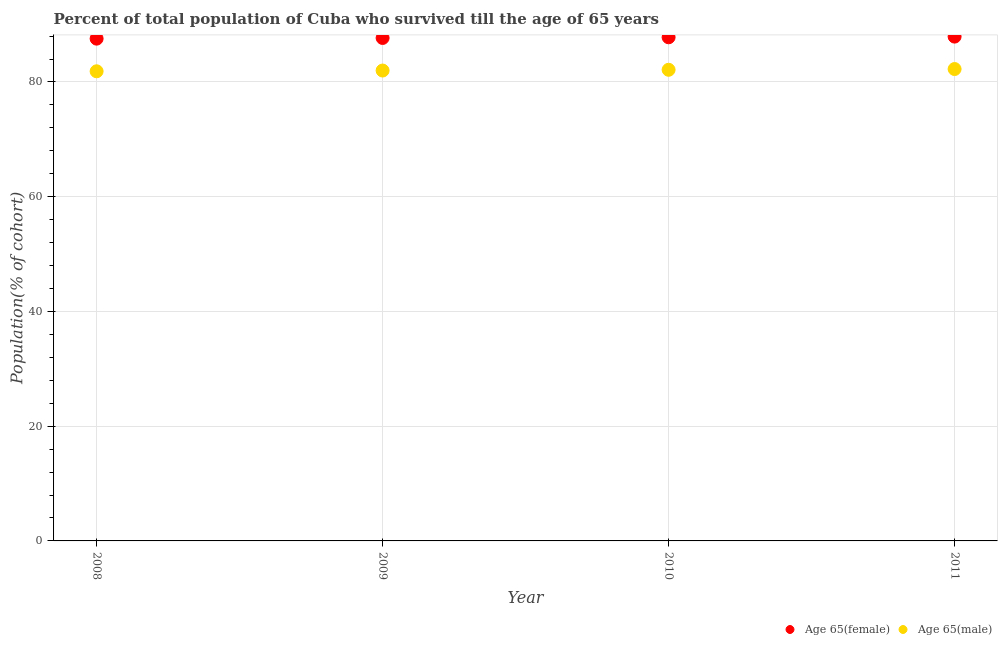How many different coloured dotlines are there?
Ensure brevity in your answer.  2. Is the number of dotlines equal to the number of legend labels?
Your response must be concise. Yes. What is the percentage of male population who survived till age of 65 in 2011?
Give a very brief answer. 82.26. Across all years, what is the maximum percentage of female population who survived till age of 65?
Keep it short and to the point. 87.91. Across all years, what is the minimum percentage of female population who survived till age of 65?
Provide a short and direct response. 87.55. In which year was the percentage of female population who survived till age of 65 minimum?
Your answer should be very brief. 2008. What is the total percentage of female population who survived till age of 65 in the graph?
Your answer should be compact. 350.92. What is the difference between the percentage of male population who survived till age of 65 in 2009 and that in 2011?
Your answer should be compact. -0.26. What is the difference between the percentage of female population who survived till age of 65 in 2010 and the percentage of male population who survived till age of 65 in 2008?
Your answer should be very brief. 5.93. What is the average percentage of male population who survived till age of 65 per year?
Your answer should be compact. 82.06. In the year 2008, what is the difference between the percentage of male population who survived till age of 65 and percentage of female population who survived till age of 65?
Offer a very short reply. -5.69. What is the ratio of the percentage of male population who survived till age of 65 in 2010 to that in 2011?
Provide a short and direct response. 1. Is the difference between the percentage of female population who survived till age of 65 in 2008 and 2009 greater than the difference between the percentage of male population who survived till age of 65 in 2008 and 2009?
Your answer should be very brief. Yes. What is the difference between the highest and the second highest percentage of female population who survived till age of 65?
Give a very brief answer. 0.12. What is the difference between the highest and the lowest percentage of male population who survived till age of 65?
Provide a short and direct response. 0.39. In how many years, is the percentage of male population who survived till age of 65 greater than the average percentage of male population who survived till age of 65 taken over all years?
Offer a terse response. 2. Is the sum of the percentage of male population who survived till age of 65 in 2008 and 2011 greater than the maximum percentage of female population who survived till age of 65 across all years?
Your answer should be very brief. Yes. Does the percentage of female population who survived till age of 65 monotonically increase over the years?
Ensure brevity in your answer.  Yes. Is the percentage of male population who survived till age of 65 strictly less than the percentage of female population who survived till age of 65 over the years?
Offer a terse response. Yes. What is the difference between two consecutive major ticks on the Y-axis?
Offer a terse response. 20. Are the values on the major ticks of Y-axis written in scientific E-notation?
Your response must be concise. No. Does the graph contain grids?
Provide a succinct answer. Yes. How many legend labels are there?
Provide a short and direct response. 2. How are the legend labels stacked?
Keep it short and to the point. Horizontal. What is the title of the graph?
Offer a terse response. Percent of total population of Cuba who survived till the age of 65 years. What is the label or title of the Y-axis?
Offer a terse response. Population(% of cohort). What is the Population(% of cohort) of Age 65(female) in 2008?
Provide a short and direct response. 87.55. What is the Population(% of cohort) in Age 65(male) in 2008?
Provide a succinct answer. 81.86. What is the Population(% of cohort) in Age 65(female) in 2009?
Provide a short and direct response. 87.67. What is the Population(% of cohort) in Age 65(male) in 2009?
Provide a succinct answer. 81.99. What is the Population(% of cohort) in Age 65(female) in 2010?
Offer a terse response. 87.79. What is the Population(% of cohort) in Age 65(male) in 2010?
Your answer should be very brief. 82.12. What is the Population(% of cohort) in Age 65(female) in 2011?
Ensure brevity in your answer.  87.91. What is the Population(% of cohort) in Age 65(male) in 2011?
Provide a short and direct response. 82.26. Across all years, what is the maximum Population(% of cohort) of Age 65(female)?
Keep it short and to the point. 87.91. Across all years, what is the maximum Population(% of cohort) in Age 65(male)?
Your answer should be compact. 82.26. Across all years, what is the minimum Population(% of cohort) in Age 65(female)?
Make the answer very short. 87.55. Across all years, what is the minimum Population(% of cohort) of Age 65(male)?
Provide a succinct answer. 81.86. What is the total Population(% of cohort) of Age 65(female) in the graph?
Ensure brevity in your answer.  350.92. What is the total Population(% of cohort) in Age 65(male) in the graph?
Ensure brevity in your answer.  328.24. What is the difference between the Population(% of cohort) in Age 65(female) in 2008 and that in 2009?
Provide a succinct answer. -0.12. What is the difference between the Population(% of cohort) of Age 65(male) in 2008 and that in 2009?
Your answer should be very brief. -0.13. What is the difference between the Population(% of cohort) in Age 65(female) in 2008 and that in 2010?
Provide a short and direct response. -0.24. What is the difference between the Population(% of cohort) in Age 65(male) in 2008 and that in 2010?
Provide a short and direct response. -0.26. What is the difference between the Population(% of cohort) of Age 65(female) in 2008 and that in 2011?
Ensure brevity in your answer.  -0.35. What is the difference between the Population(% of cohort) in Age 65(male) in 2008 and that in 2011?
Provide a short and direct response. -0.39. What is the difference between the Population(% of cohort) in Age 65(female) in 2009 and that in 2010?
Your answer should be very brief. -0.12. What is the difference between the Population(% of cohort) of Age 65(male) in 2009 and that in 2010?
Keep it short and to the point. -0.13. What is the difference between the Population(% of cohort) in Age 65(female) in 2009 and that in 2011?
Make the answer very short. -0.24. What is the difference between the Population(% of cohort) in Age 65(male) in 2009 and that in 2011?
Provide a short and direct response. -0.26. What is the difference between the Population(% of cohort) in Age 65(female) in 2010 and that in 2011?
Provide a short and direct response. -0.12. What is the difference between the Population(% of cohort) of Age 65(male) in 2010 and that in 2011?
Offer a very short reply. -0.13. What is the difference between the Population(% of cohort) of Age 65(female) in 2008 and the Population(% of cohort) of Age 65(male) in 2009?
Your response must be concise. 5.56. What is the difference between the Population(% of cohort) of Age 65(female) in 2008 and the Population(% of cohort) of Age 65(male) in 2010?
Ensure brevity in your answer.  5.43. What is the difference between the Population(% of cohort) in Age 65(female) in 2008 and the Population(% of cohort) in Age 65(male) in 2011?
Provide a succinct answer. 5.3. What is the difference between the Population(% of cohort) in Age 65(female) in 2009 and the Population(% of cohort) in Age 65(male) in 2010?
Your answer should be compact. 5.55. What is the difference between the Population(% of cohort) in Age 65(female) in 2009 and the Population(% of cohort) in Age 65(male) in 2011?
Your answer should be compact. 5.42. What is the difference between the Population(% of cohort) in Age 65(female) in 2010 and the Population(% of cohort) in Age 65(male) in 2011?
Ensure brevity in your answer.  5.53. What is the average Population(% of cohort) of Age 65(female) per year?
Your answer should be compact. 87.73. What is the average Population(% of cohort) of Age 65(male) per year?
Offer a very short reply. 82.06. In the year 2008, what is the difference between the Population(% of cohort) of Age 65(female) and Population(% of cohort) of Age 65(male)?
Provide a succinct answer. 5.69. In the year 2009, what is the difference between the Population(% of cohort) in Age 65(female) and Population(% of cohort) in Age 65(male)?
Provide a succinct answer. 5.68. In the year 2010, what is the difference between the Population(% of cohort) in Age 65(female) and Population(% of cohort) in Age 65(male)?
Offer a terse response. 5.66. In the year 2011, what is the difference between the Population(% of cohort) of Age 65(female) and Population(% of cohort) of Age 65(male)?
Give a very brief answer. 5.65. What is the ratio of the Population(% of cohort) of Age 65(female) in 2008 to that in 2010?
Provide a succinct answer. 1. What is the ratio of the Population(% of cohort) in Age 65(female) in 2008 to that in 2011?
Your answer should be very brief. 1. What is the ratio of the Population(% of cohort) of Age 65(male) in 2008 to that in 2011?
Provide a short and direct response. 1. What is the ratio of the Population(% of cohort) of Age 65(female) in 2009 to that in 2010?
Keep it short and to the point. 1. What is the ratio of the Population(% of cohort) in Age 65(male) in 2009 to that in 2011?
Provide a succinct answer. 1. What is the difference between the highest and the second highest Population(% of cohort) in Age 65(female)?
Your answer should be compact. 0.12. What is the difference between the highest and the second highest Population(% of cohort) of Age 65(male)?
Provide a succinct answer. 0.13. What is the difference between the highest and the lowest Population(% of cohort) of Age 65(female)?
Provide a short and direct response. 0.35. What is the difference between the highest and the lowest Population(% of cohort) of Age 65(male)?
Give a very brief answer. 0.39. 